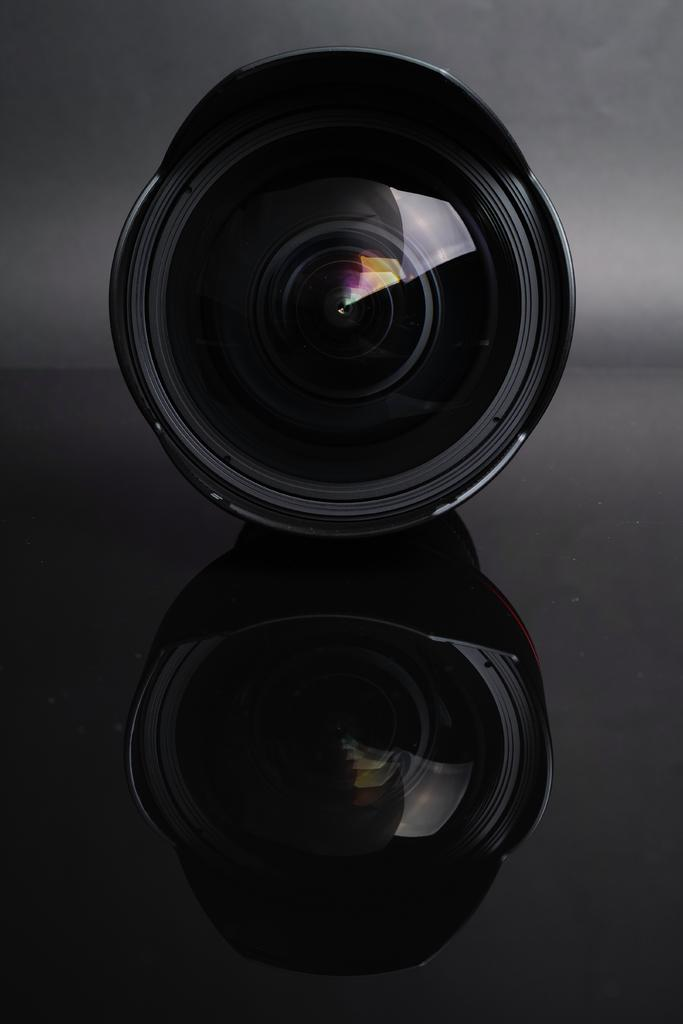What object is the main focus of the image? There is a camera in the image. Where is the camera located in the image? The camera is placed on a surface. How many geese are being punished for eating the meat in the image? There are no geese or meat present in the image; it only features a camera placed on a surface. 